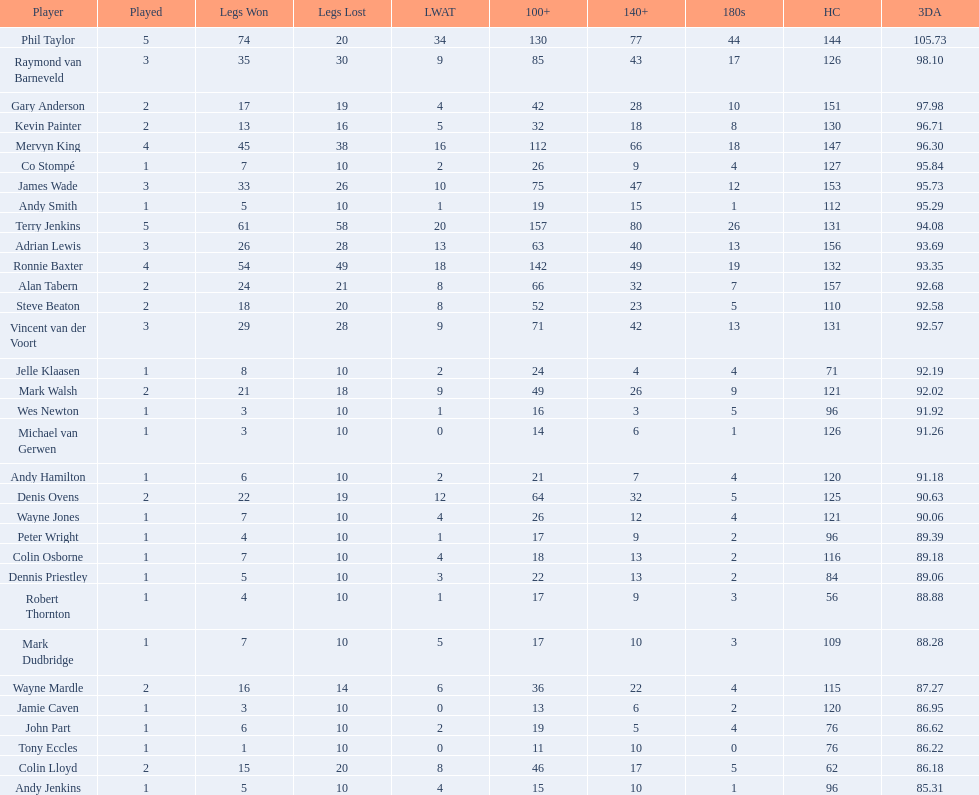Who won the highest number of legs in the 2009 world matchplay? Phil Taylor. 